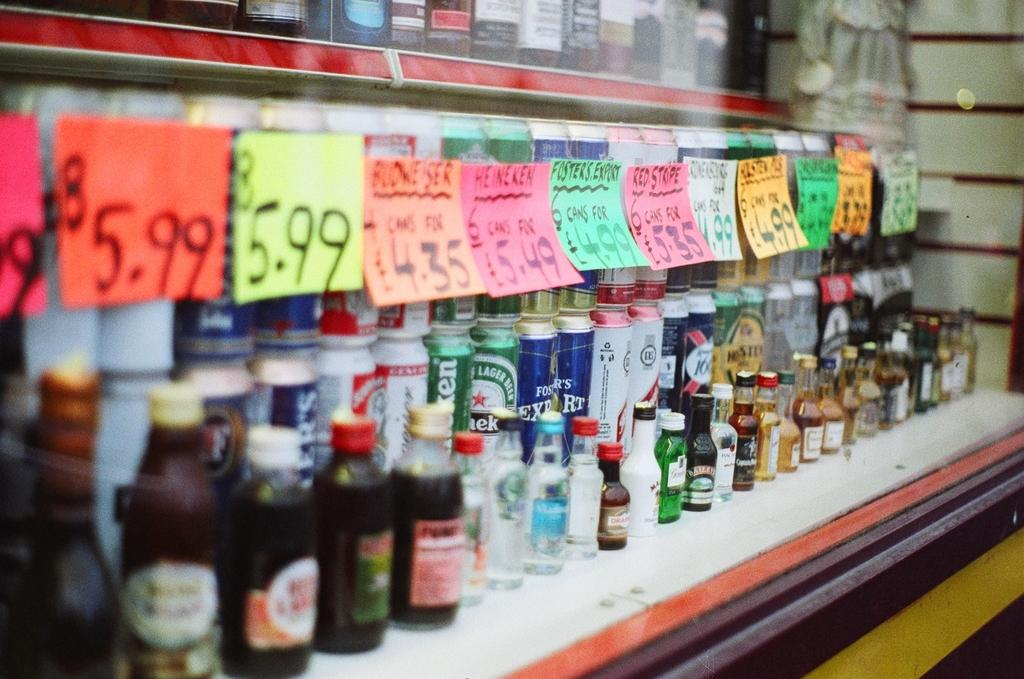<image>
Give a short and clear explanation of the subsequent image. Green Heineken can under a pink sign that says $5.49 